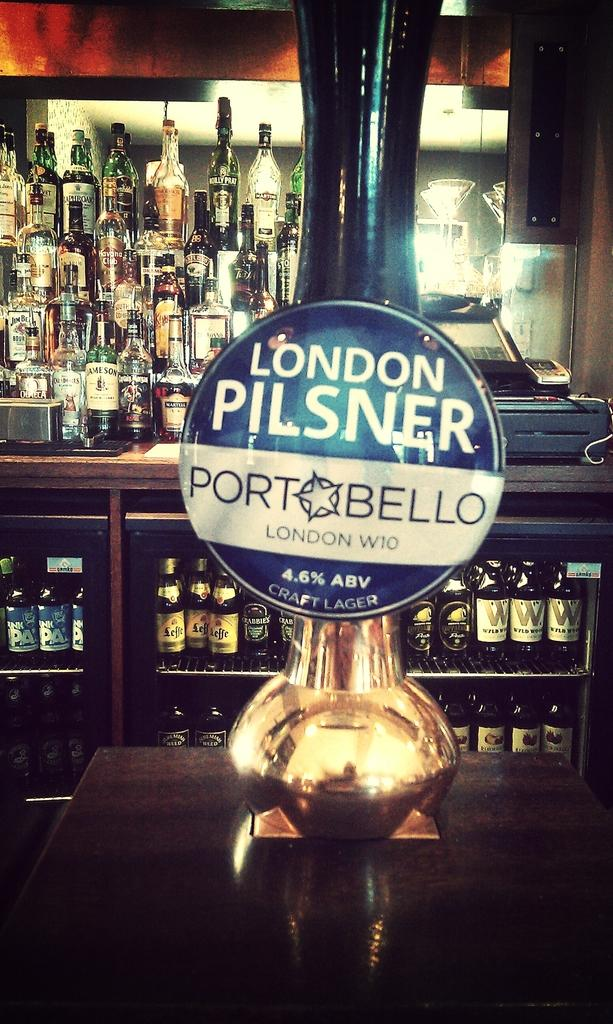Provide a one-sentence caption for the provided image. A beer tap  has London pilsner port bello beer. 